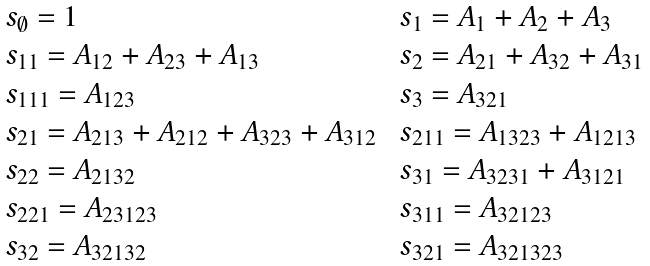Convert formula to latex. <formula><loc_0><loc_0><loc_500><loc_500>\begin{array} { l l } \ s _ { \emptyset } = 1 & \ s _ { 1 } = A _ { 1 } + A _ { 2 } + A _ { 3 } \\ \ s _ { 1 1 } = A _ { 1 2 } + A _ { 2 3 } + A _ { 1 3 } & \ s _ { 2 } = A _ { 2 1 } + A _ { 3 2 } + A _ { 3 1 } \\ \ s _ { 1 1 1 } = A _ { 1 2 3 } & \ s _ { 3 } = A _ { 3 2 1 } \\ \ s _ { 2 1 } = A _ { 2 1 3 } + A _ { 2 1 2 } + A _ { 3 2 3 } + A _ { 3 1 2 } & \ s _ { 2 1 1 } = A _ { 1 3 2 3 } + A _ { 1 2 1 3 } \\ \ s _ { 2 2 } = A _ { 2 1 3 2 } & \ s _ { 3 1 } = A _ { 3 2 3 1 } + A _ { 3 1 2 1 } \\ \ s _ { 2 2 1 } = A _ { 2 3 1 2 3 } & \ s _ { 3 1 1 } = A _ { 3 2 1 2 3 } \\ \ s _ { 3 2 } = A _ { 3 2 1 3 2 } & \ s _ { 3 2 1 } = A _ { 3 2 1 3 2 3 } \end{array}</formula> 